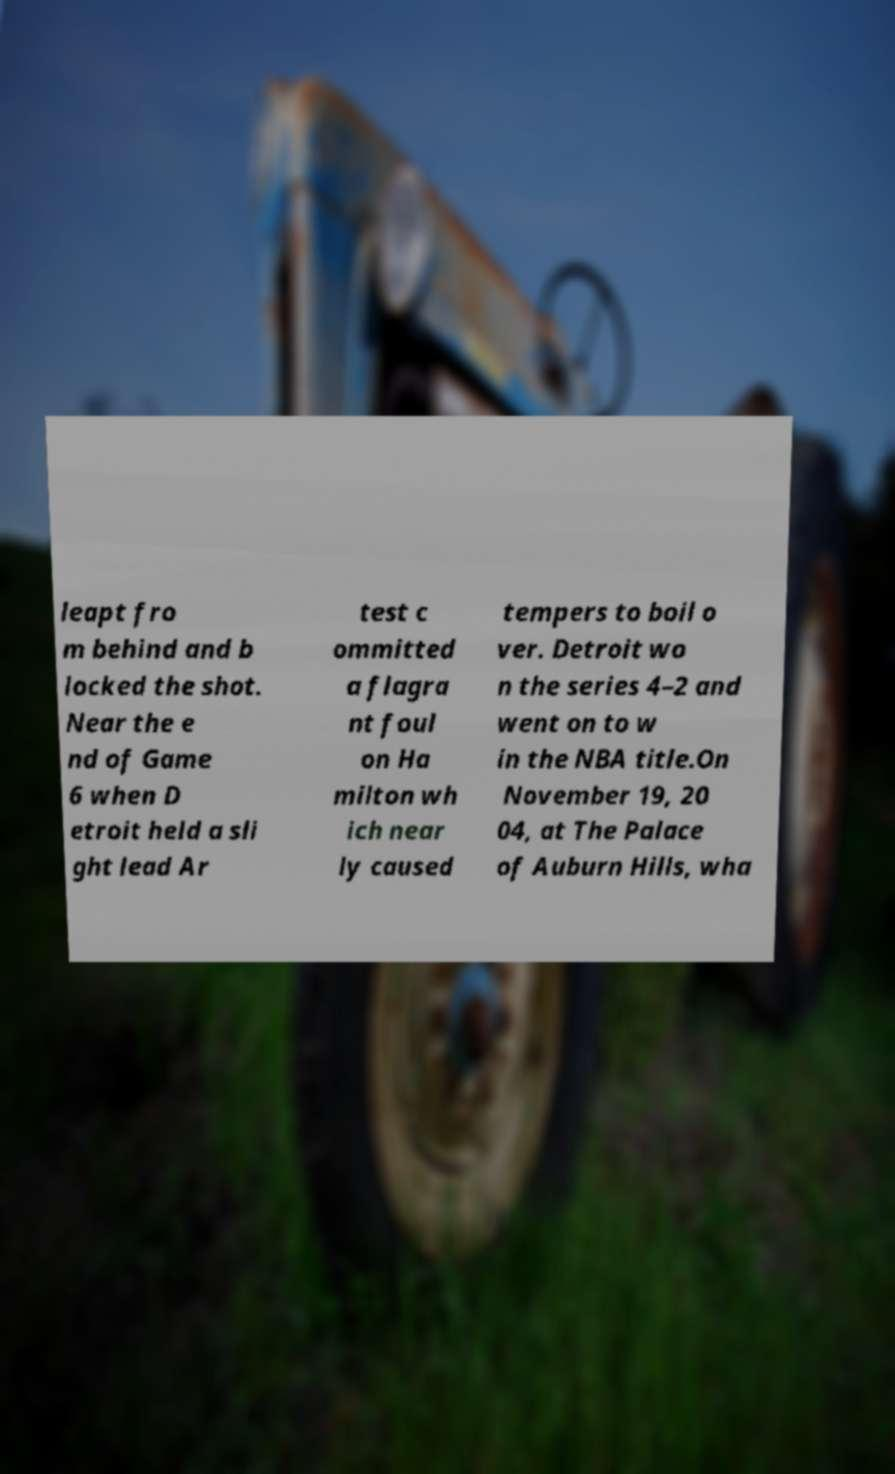For documentation purposes, I need the text within this image transcribed. Could you provide that? leapt fro m behind and b locked the shot. Near the e nd of Game 6 when D etroit held a sli ght lead Ar test c ommitted a flagra nt foul on Ha milton wh ich near ly caused tempers to boil o ver. Detroit wo n the series 4–2 and went on to w in the NBA title.On November 19, 20 04, at The Palace of Auburn Hills, wha 